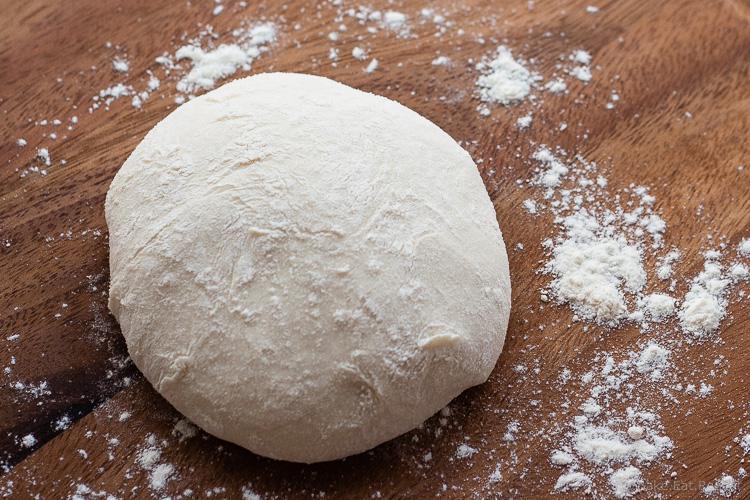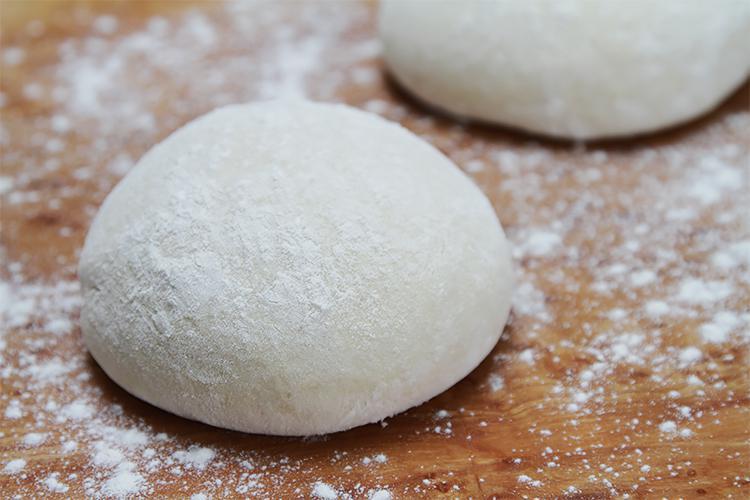The first image is the image on the left, the second image is the image on the right. Assess this claim about the two images: "Dough is resting on a wooden surface in both pictures.". Correct or not? Answer yes or no. Yes. The first image is the image on the left, the second image is the image on the right. Evaluate the accuracy of this statement regarding the images: "There are exactly two balls of dough in one of the images.". Is it true? Answer yes or no. Yes. 